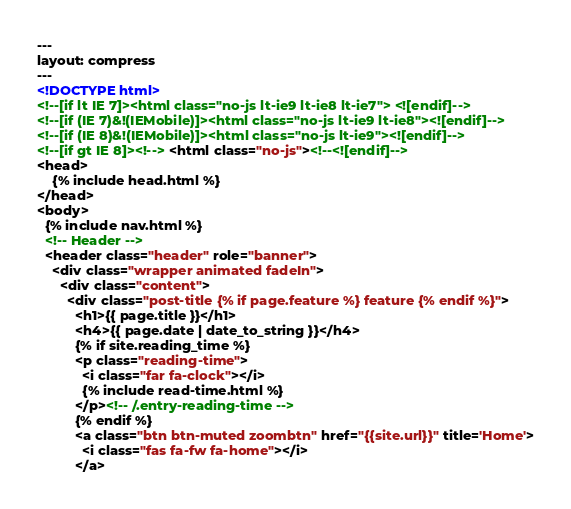Convert code to text. <code><loc_0><loc_0><loc_500><loc_500><_HTML_>---
layout: compress
---
<!DOCTYPE html>
<!--[if lt IE 7]><html class="no-js lt-ie9 lt-ie8 lt-ie7"> <![endif]-->
<!--[if (IE 7)&!(IEMobile)]><html class="no-js lt-ie9 lt-ie8"><![endif]-->
<!--[if (IE 8)&!(IEMobile)]><html class="no-js lt-ie9"><![endif]-->
<!--[if gt IE 8]><!--> <html class="no-js"><!--<![endif]-->
<head>
    {% include head.html %}
</head>
<body>
  {% include nav.html %}
  <!-- Header -->
  <header class="header" role="banner">
    <div class="wrapper animated fadeIn">
      <div class="content">
        <div class="post-title {% if page.feature %} feature {% endif %}">
          <h1>{{ page.title }}</h1>
          <h4>{{ page.date | date_to_string }}</h4>
          {% if site.reading_time %}
          <p class="reading-time">
            <i class="far fa-clock"></i>
            {% include read-time.html %}
          </p><!-- /.entry-reading-time -->
          {% endif %}
          <a class="btn btn-muted zoombtn" href="{{site.url}}" title='Home'>
            <i class="fas fa-fw fa-home"></i>
          </a></code> 